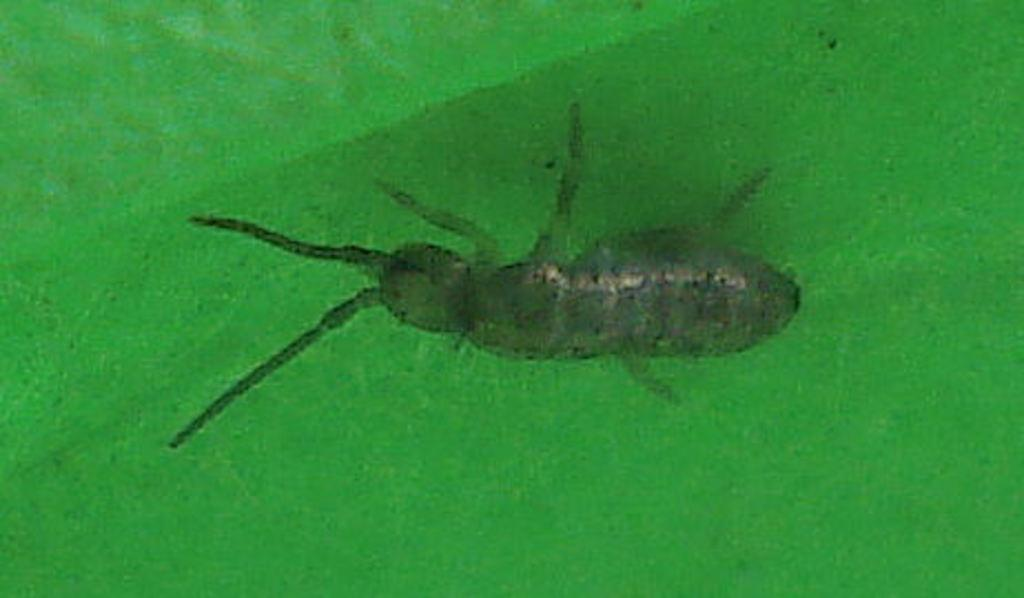What type of creature is present in the image? There is an insect in the image. Where is the insect located? The insect is on a leaf. How many horses are visible in the image? There are no horses present in the image; it features an insect on a leaf. What type of gold object can be seen in the image? There is no gold object present in the image. 